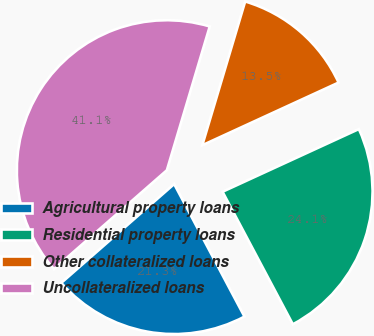Convert chart to OTSL. <chart><loc_0><loc_0><loc_500><loc_500><pie_chart><fcel>Agricultural property loans<fcel>Residential property loans<fcel>Other collateralized loans<fcel>Uncollateralized loans<nl><fcel>21.32%<fcel>24.1%<fcel>13.53%<fcel>41.06%<nl></chart> 